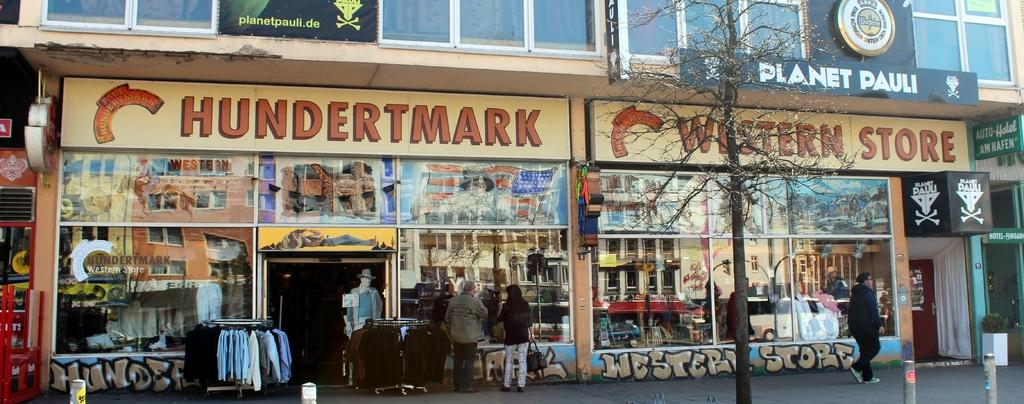What is the main structure in the center of the image? There is a building in the center of the image. What type of barrier can be seen in the image? There is a wall in the image. What type of window treatment is present in the image? There is a curtain in the image. What type of plant is visible in the image? There is a tree in the image. What type of material is present in the image that allows light to pass through? There is glass in the image. What type of signage is present in the image? There are boards with text in the image. Are there any human subjects in the image? Yes, there are people in the image. What other objects can be seen in the image besides the ones mentioned? There are other objects in the image, but their specific details are not provided in the facts. How does the user compare the knowledge of the cub in the image? There is no cub or knowledge-related information present in the image. 